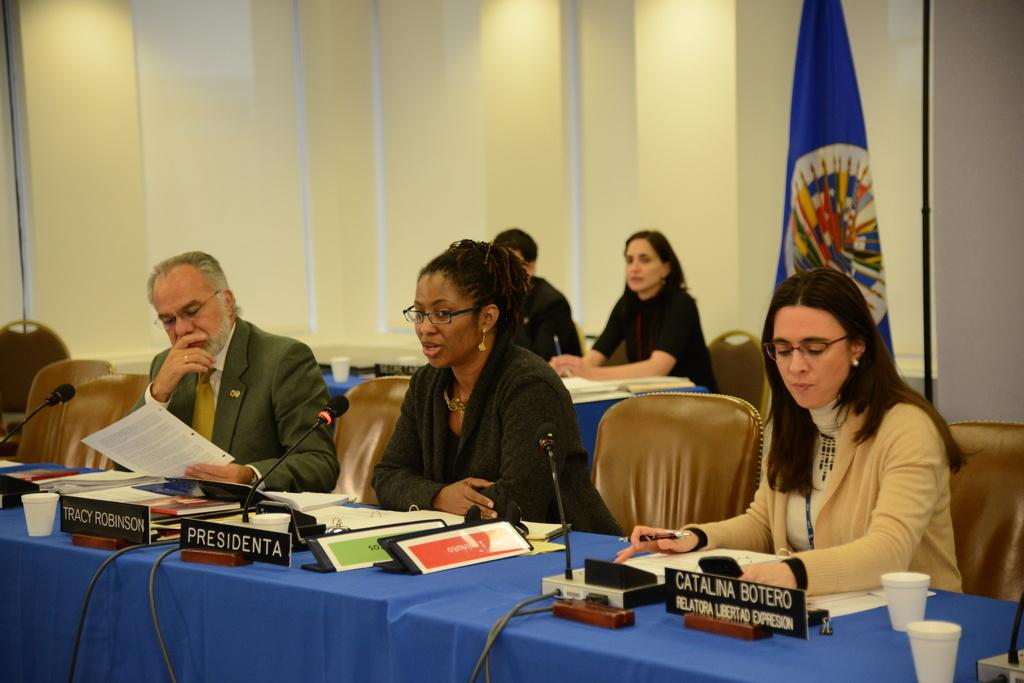What are the persons in the image doing? The persons in the image are sitting on chairs. What can be seen on the tables in front of the persons? There are objects on the tables in front of the persons. What is visible behind the persons? There is a wall visible behind the persons. Can you see a sink in the image? There is no sink present in the image. Are there any birds visible in the image? There are no birds visible in the image. 